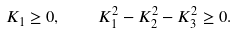Convert formula to latex. <formula><loc_0><loc_0><loc_500><loc_500>K _ { 1 } \geq 0 , \quad K _ { 1 } ^ { 2 } - K _ { 2 } ^ { 2 } - K _ { 3 } ^ { 2 } \geq 0 .</formula> 